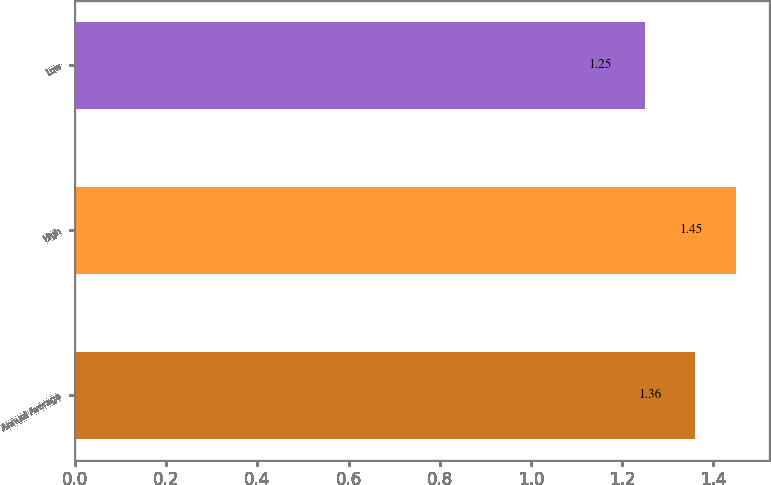Convert chart. <chart><loc_0><loc_0><loc_500><loc_500><bar_chart><fcel>Annual Average<fcel>High<fcel>Low<nl><fcel>1.36<fcel>1.45<fcel>1.25<nl></chart> 